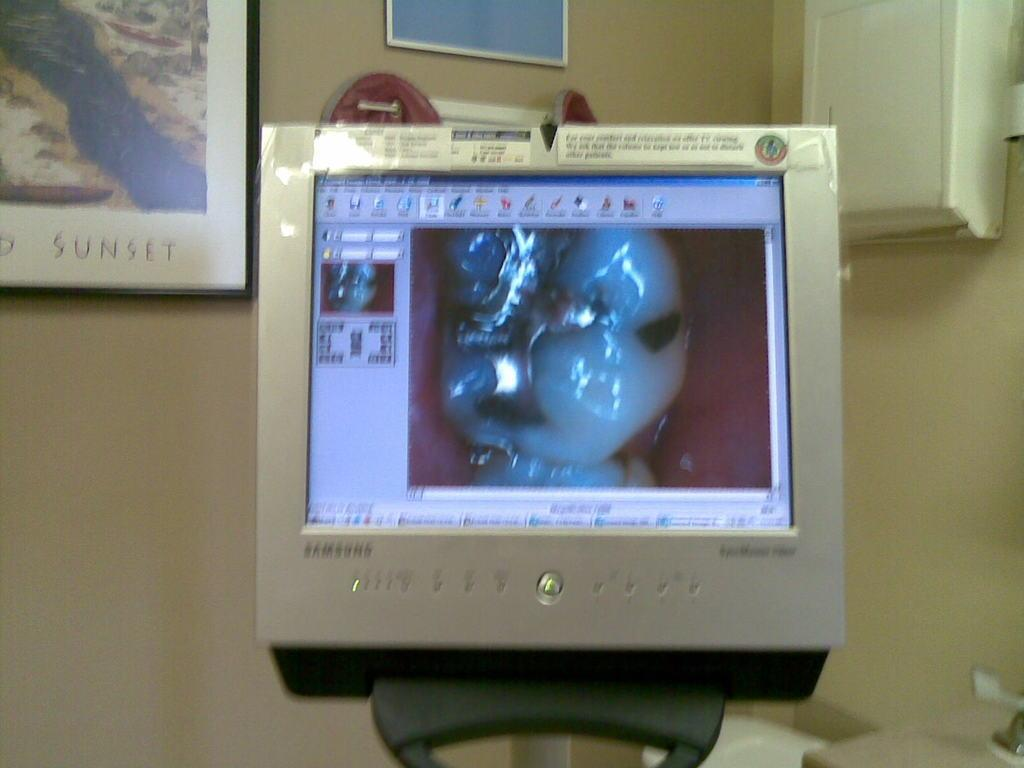What electronic device is visible in the image? There is a monitor in the image. What can be seen on the wall in the image? There are couple photo frames on the wall in the image. Can you see a river flowing behind the monitor in the image? There is no river visible in the image; it only features a monitor and couple photo frames on the wall. What type of material is the silk used for the photo frames in the image? There is no mention of silk or any specific material used for the photo frames in the image. 